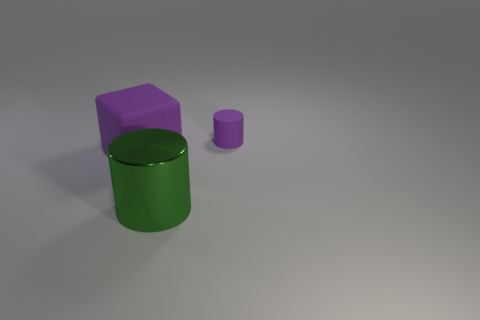Subtract all blue cylinders. Subtract all blue spheres. How many cylinders are left? 2 Add 2 large gray metallic blocks. How many objects exist? 5 Subtract all cylinders. How many objects are left? 1 Add 3 metal cylinders. How many metal cylinders are left? 4 Add 1 metal cylinders. How many metal cylinders exist? 2 Subtract 0 blue balls. How many objects are left? 3 Subtract all matte cylinders. Subtract all purple cylinders. How many objects are left? 1 